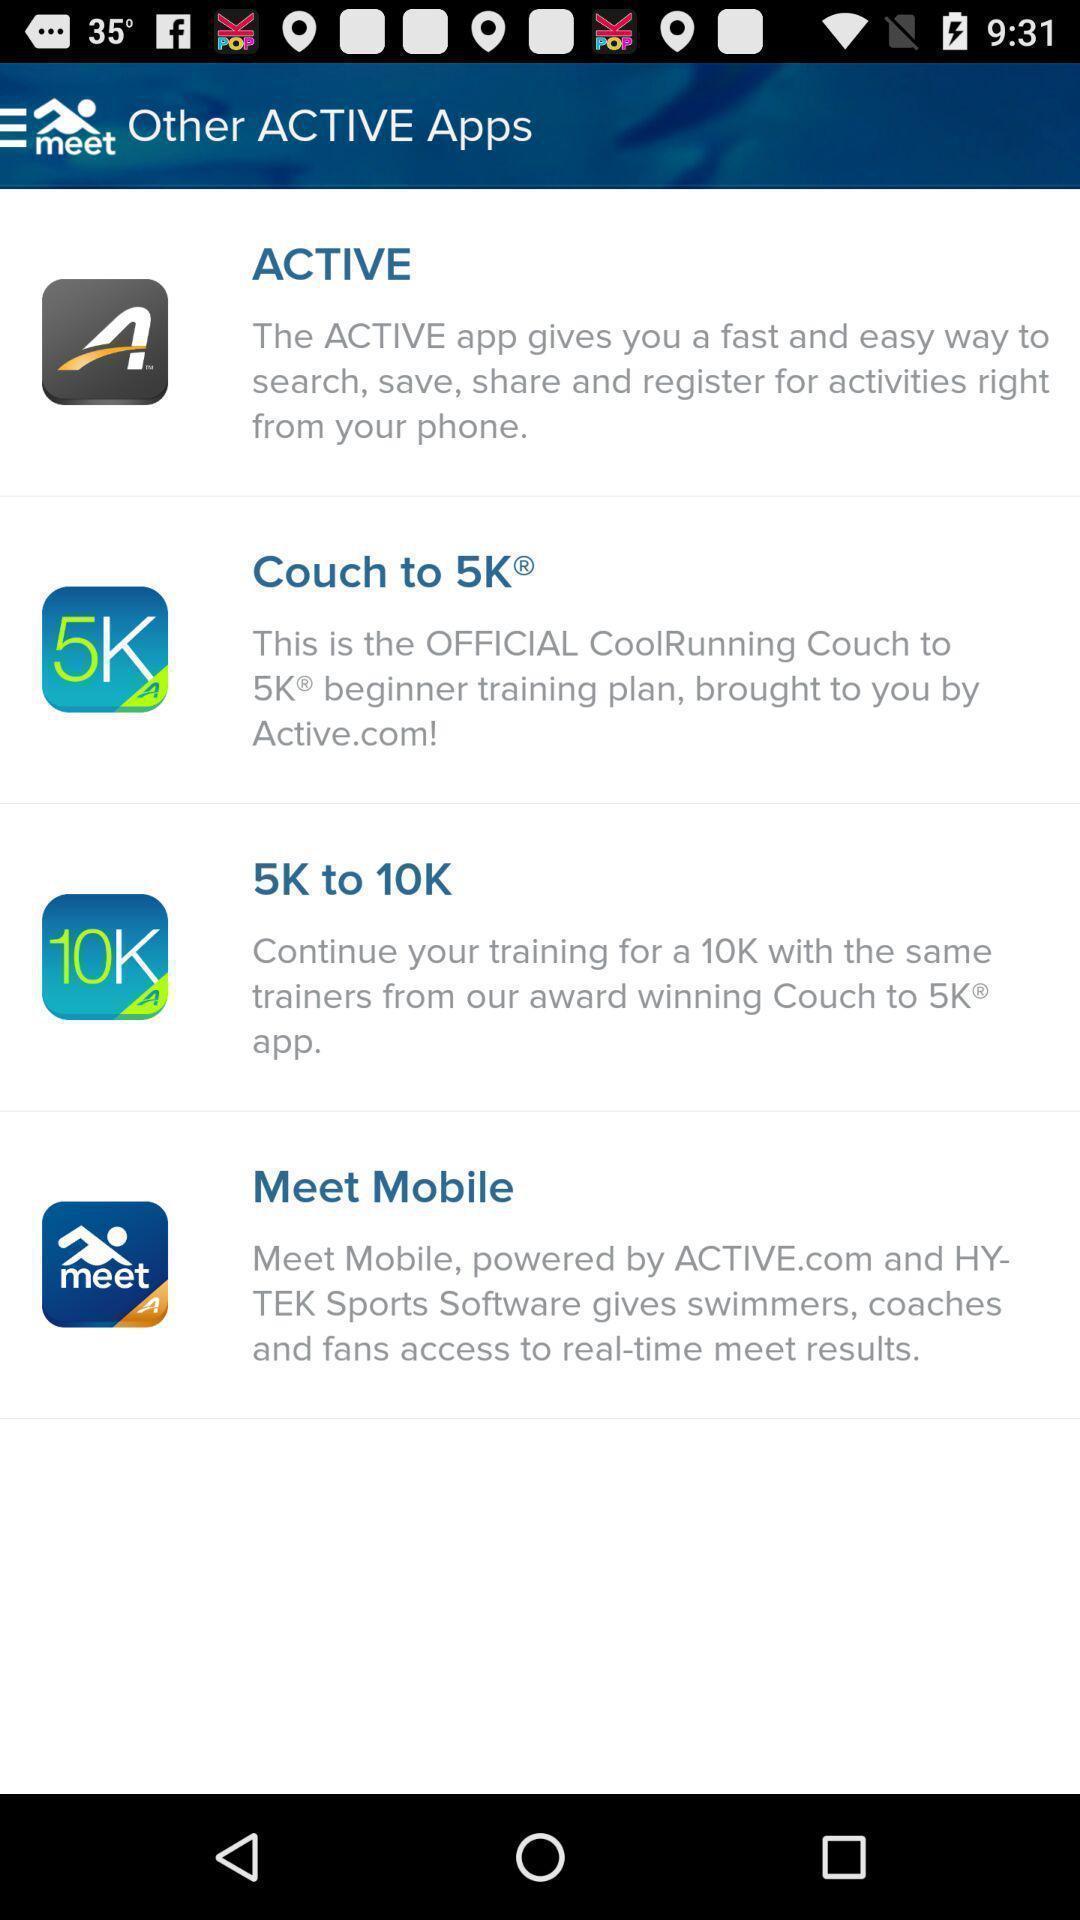What details can you identify in this image? Page displaying other active apps available for an app. 